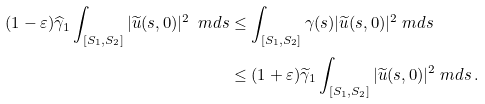<formula> <loc_0><loc_0><loc_500><loc_500>( 1 - \varepsilon ) \widehat { \gamma } _ { 1 } \int _ { [ S _ { 1 } , S _ { 2 } ] } | \widetilde { u } ( s , 0 ) | ^ { 2 } \ m d s & \leq \int _ { [ S _ { 1 } , S _ { 2 } ] } \gamma ( s ) | \widetilde { u } ( s , 0 ) | ^ { 2 } \ m d s \\ & \leq ( 1 + \varepsilon ) \widetilde { \gamma } _ { 1 } \int _ { [ S _ { 1 } , S _ { 2 } ] } | \widetilde { u } ( s , 0 ) | ^ { 2 } \ m d s \, .</formula> 